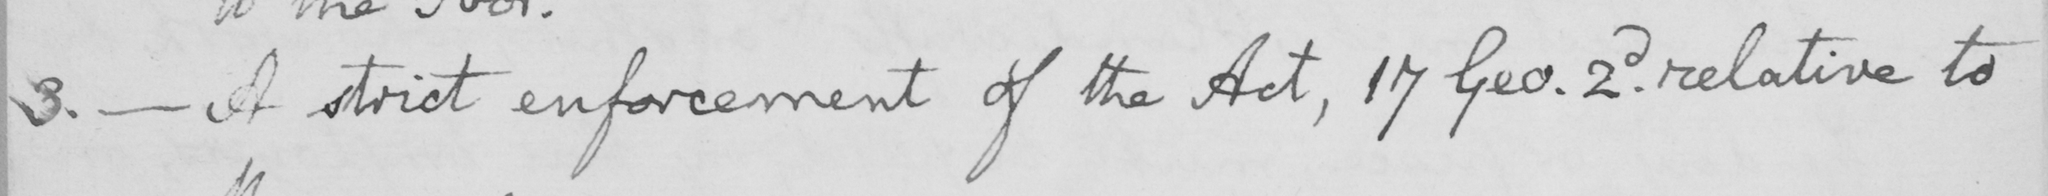Transcribe the text shown in this historical manuscript line. 3 .  _  A strict enforcement of the Act , 17 Geo . 2d . relative to 